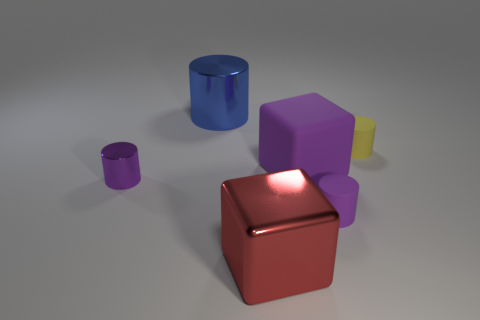Subtract all big metallic cylinders. How many cylinders are left? 3 Subtract 0 green spheres. How many objects are left? 6 Subtract all cubes. How many objects are left? 4 Subtract 2 cubes. How many cubes are left? 0 Subtract all brown cubes. Subtract all brown cylinders. How many cubes are left? 2 Subtract all blue cylinders. How many red cubes are left? 1 Subtract all red matte cylinders. Subtract all large rubber cubes. How many objects are left? 5 Add 6 blocks. How many blocks are left? 8 Add 1 small blue metallic objects. How many small blue metallic objects exist? 1 Add 1 big cubes. How many objects exist? 7 